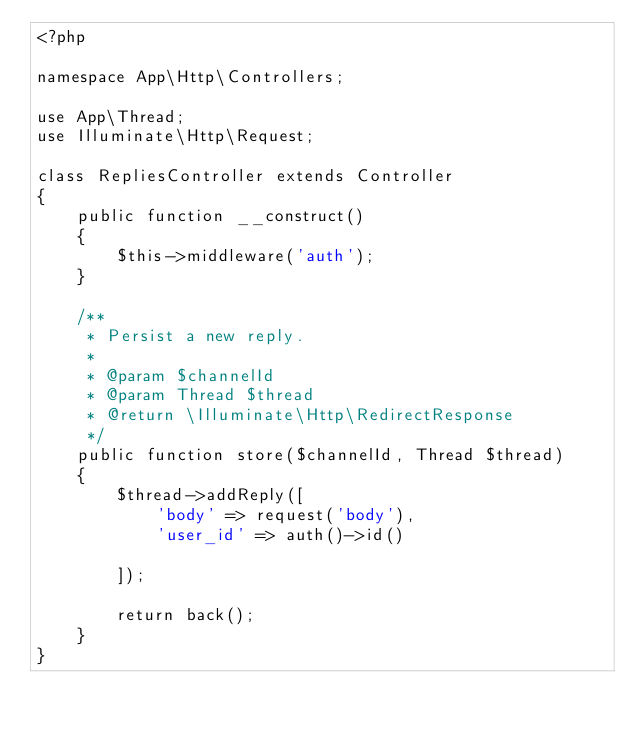Convert code to text. <code><loc_0><loc_0><loc_500><loc_500><_PHP_><?php

namespace App\Http\Controllers;

use App\Thread;
use Illuminate\Http\Request;

class RepliesController extends Controller
{
    public function __construct()
    {
        $this->middleware('auth');
    }
    
    /**
     * Persist a new reply.
     * 
     * @param $channelId
     * @param Thread $thread
     * @return \Illuminate\Http\RedirectResponse
     */
    public function store($channelId, Thread $thread)
    {
        $thread->addReply([
            'body' => request('body'),
            'user_id' => auth()->id()

        ]);

        return back();
    }
}
</code> 